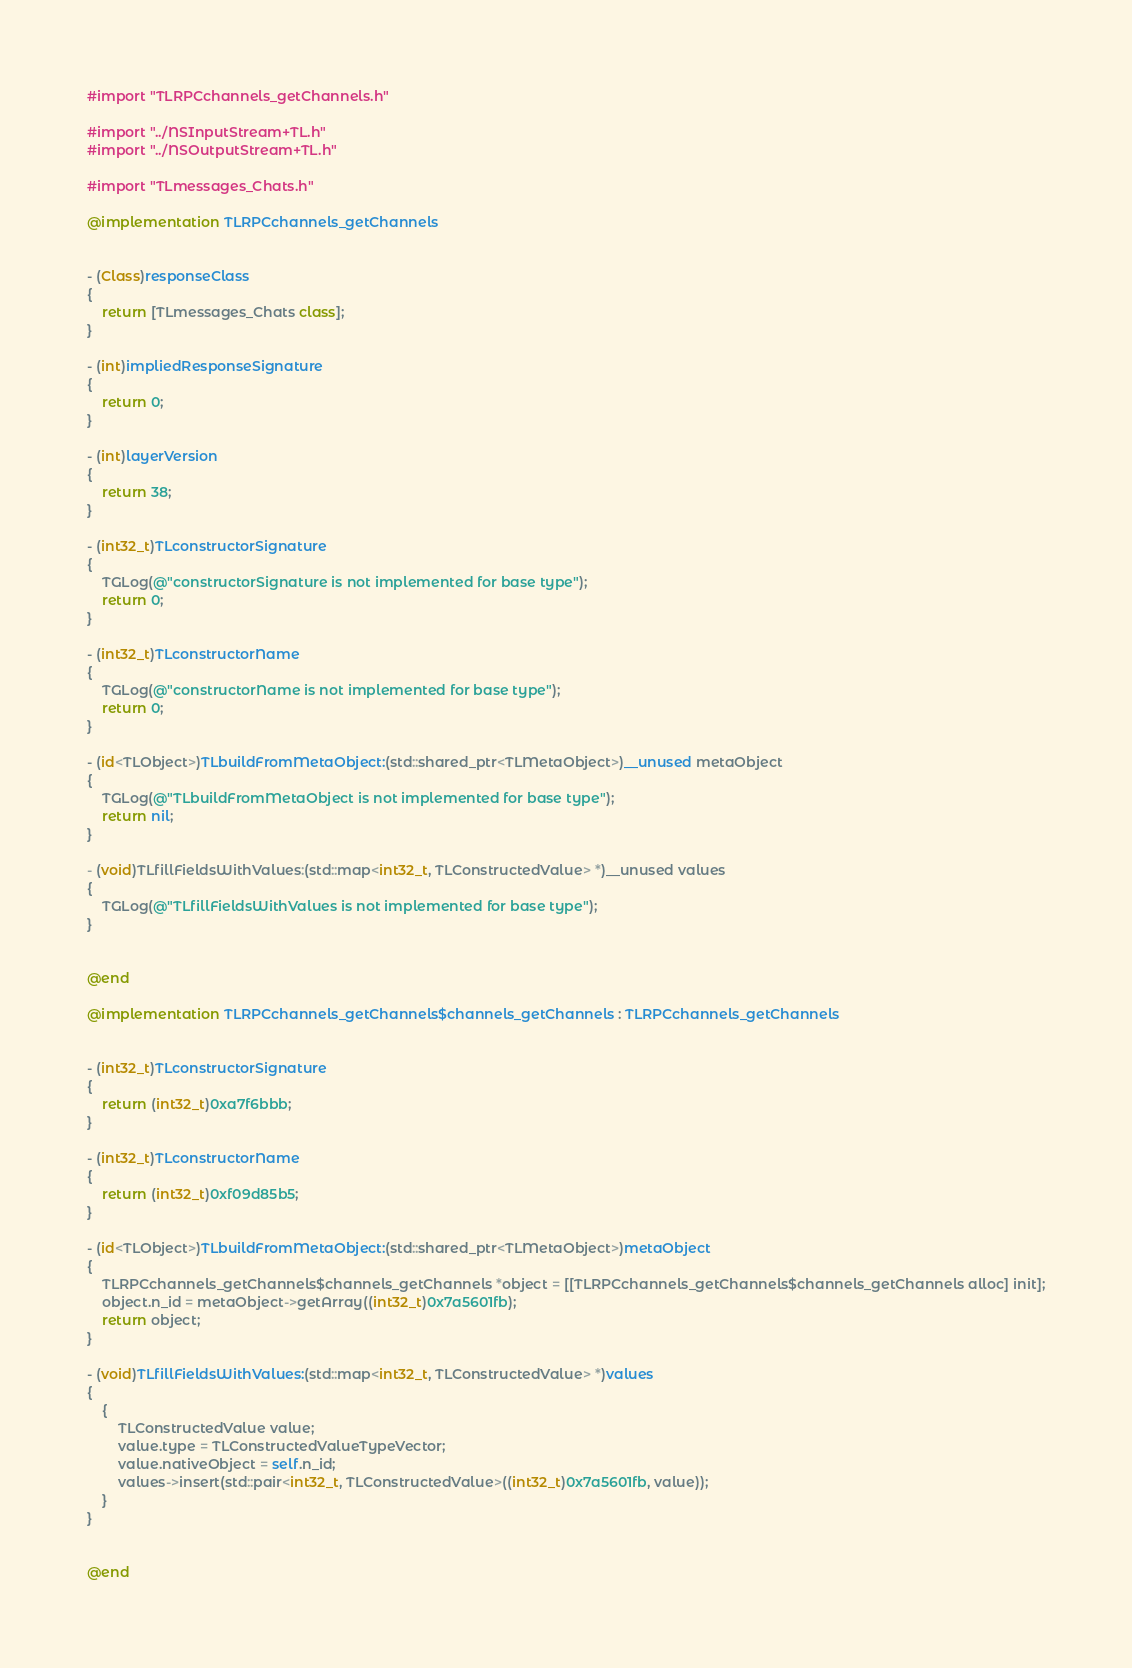Convert code to text. <code><loc_0><loc_0><loc_500><loc_500><_ObjectiveC_>#import "TLRPCchannels_getChannels.h"

#import "../NSInputStream+TL.h"
#import "../NSOutputStream+TL.h"

#import "TLmessages_Chats.h"

@implementation TLRPCchannels_getChannels


- (Class)responseClass
{
    return [TLmessages_Chats class];
}

- (int)impliedResponseSignature
{
    return 0;
}

- (int)layerVersion
{
    return 38;
}

- (int32_t)TLconstructorSignature
{
    TGLog(@"constructorSignature is not implemented for base type");
    return 0;
}

- (int32_t)TLconstructorName
{
    TGLog(@"constructorName is not implemented for base type");
    return 0;
}

- (id<TLObject>)TLbuildFromMetaObject:(std::shared_ptr<TLMetaObject>)__unused metaObject
{
    TGLog(@"TLbuildFromMetaObject is not implemented for base type");
    return nil;
}

- (void)TLfillFieldsWithValues:(std::map<int32_t, TLConstructedValue> *)__unused values
{
    TGLog(@"TLfillFieldsWithValues is not implemented for base type");
}


@end

@implementation TLRPCchannels_getChannels$channels_getChannels : TLRPCchannels_getChannels


- (int32_t)TLconstructorSignature
{
    return (int32_t)0xa7f6bbb;
}

- (int32_t)TLconstructorName
{
    return (int32_t)0xf09d85b5;
}

- (id<TLObject>)TLbuildFromMetaObject:(std::shared_ptr<TLMetaObject>)metaObject
{
    TLRPCchannels_getChannels$channels_getChannels *object = [[TLRPCchannels_getChannels$channels_getChannels alloc] init];
    object.n_id = metaObject->getArray((int32_t)0x7a5601fb);
    return object;
}

- (void)TLfillFieldsWithValues:(std::map<int32_t, TLConstructedValue> *)values
{
    {
        TLConstructedValue value;
        value.type = TLConstructedValueTypeVector;
        value.nativeObject = self.n_id;
        values->insert(std::pair<int32_t, TLConstructedValue>((int32_t)0x7a5601fb, value));
    }
}


@end

</code> 